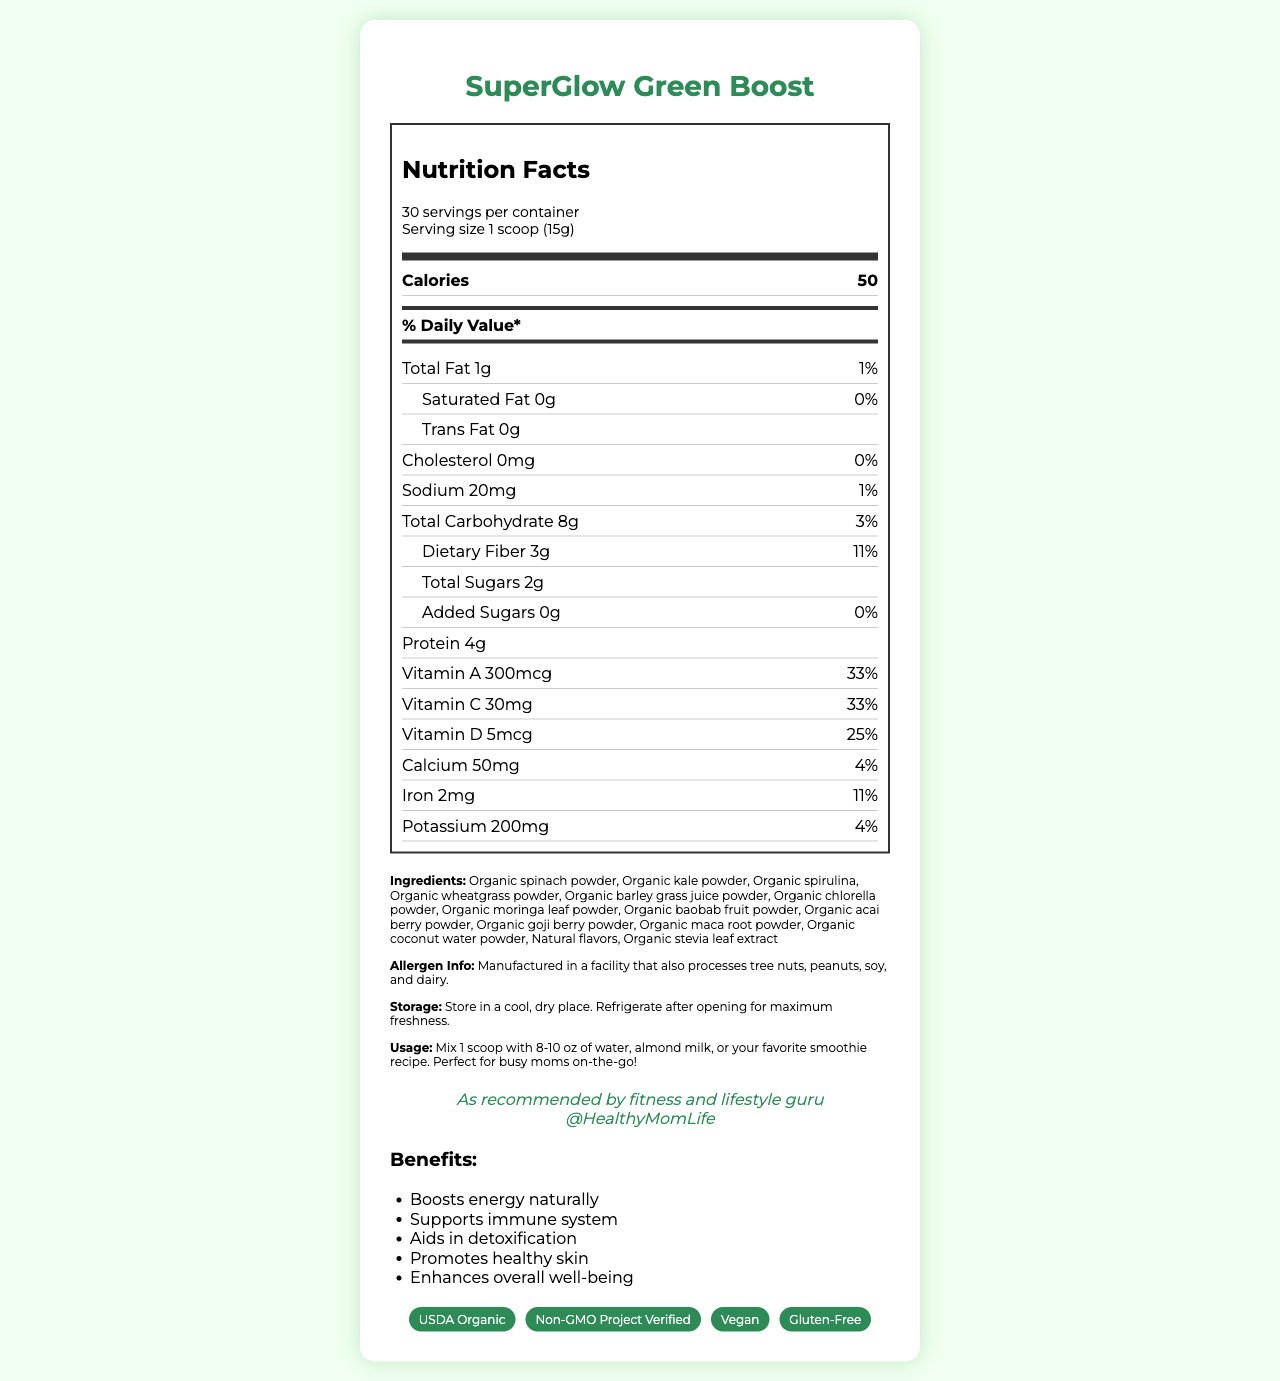When you need a quick boost of energy, what serving size should you use for the SuperGlow Green Boost? The serving size is clearly stated as "1 scoop (15g)" in the serving info section.
Answer: 1 scoop (15g) How many calories does one serving of SuperGlow Green Boost contain? The number of calories per serving is listed as 50 in the Nutrition Facts section.
Answer: 50 What percentage of the daily value of Vitamin A does one serving of SuperGlow Green Boost provide? The document states that one serving provides 33% of the daily value for Vitamin A.
Answer: 33% What is the total fat content per serving of SuperGlow Green Boost? The total fat content is given as "1g" per serving in the Nutrition Facts section.
Answer: 1g Is there any cholesterol in one serving of SuperGlow Green Boost? The amount of cholesterol is indicated as "0mg," implying that it does not contain any cholesterol.
Answer: No Which of the following ingredients are NOT in the SuperGlow Green Boost? A. Organic spinach powder B. Organic moringa leaf powder C. Organic banana powder The ingredient list includes Organic spinach powder and Organic moringa leaf powder but does not mention Organic banana powder.
Answer: C. Organic banana powder What is the recommended storage instruction after opening SuperGlow Green Boost? The storage instructions specify to "Refrigerate after opening for maximum freshness."
Answer: Refrigerate after opening for maximum freshness How should you mix the SuperGlow Green Boost powder for optimal use? A. Mix 1 scoop with 8-10 oz of water B. Mix 1 scoop with 8-10 oz of milk C. Mix 1 scoop with 8-10 oz of juice The usage instructions specify to mix 1 scoop with 8-10 oz of water, almond milk, or your favorite smoothie recipe.
Answer: A. Mix 1 scoop with 8-10 oz of water Is the SuperGlow Green Boost product vegan? The certifications section lists "Vegan" certification.
Answer: Yes What are the main benefits of using the SuperGlow Green Boost as endorsed by the influencer? The benefits section clearly lists these main benefits.
Answer: Boosts energy naturally, Supports immune system, Aids in detoxification, Promotes healthy skin, Enhances overall well-being What is the iron content in one serving of SuperGlow Green Boost as a percentage of the daily value? The document states that one serving provides 11% of the daily value for iron.
Answer: 11% What are the natural flavors used in the SuperGlow Green Boost? The document lists "Natural flavors" but does not specify what those natural flavors are.
Answer: Cannot be determined Describe the overall information provided in the SuperGlow Green Boost document. The document is designed to give a comprehensive overview of the product, including nutritional details, ingredient lists, usage and storage instructions, influencer endorsement, benefits of the product, and certifications. The information aims to help consumers understand the health benefits and proper use of the SuperGlow Green Boost.
Answer: The document contains detailed nutrition information, ingredients, allergen info, storage instructions, usage instructions, influencer endorsement, benefits, and certifications for the SuperGlow Green Boost. It includes nutritional values per serving and daily value percentages along with a list of organic ingredients and various certifications such as USDA Organic, Non-GMO Project Verified, Vegan, and Gluten-Free. 